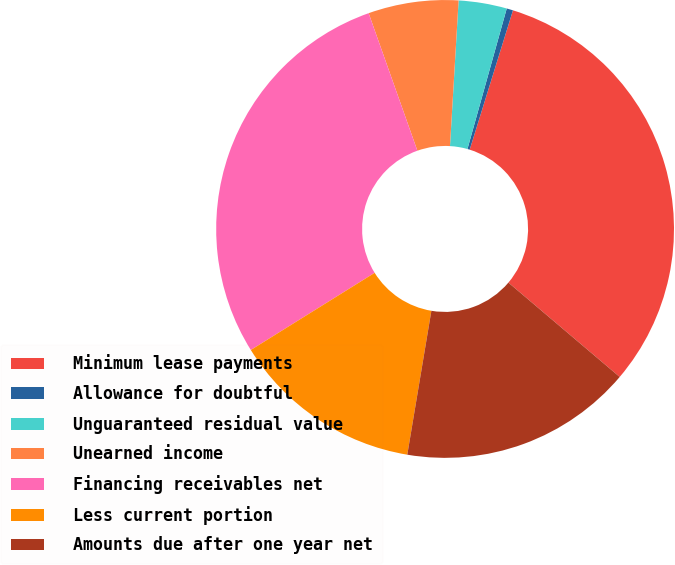Convert chart. <chart><loc_0><loc_0><loc_500><loc_500><pie_chart><fcel>Minimum lease payments<fcel>Allowance for doubtful<fcel>Unguaranteed residual value<fcel>Unearned income<fcel>Financing receivables net<fcel>Less current portion<fcel>Amounts due after one year net<nl><fcel>31.4%<fcel>0.45%<fcel>3.4%<fcel>6.36%<fcel>28.45%<fcel>13.49%<fcel>16.45%<nl></chart> 